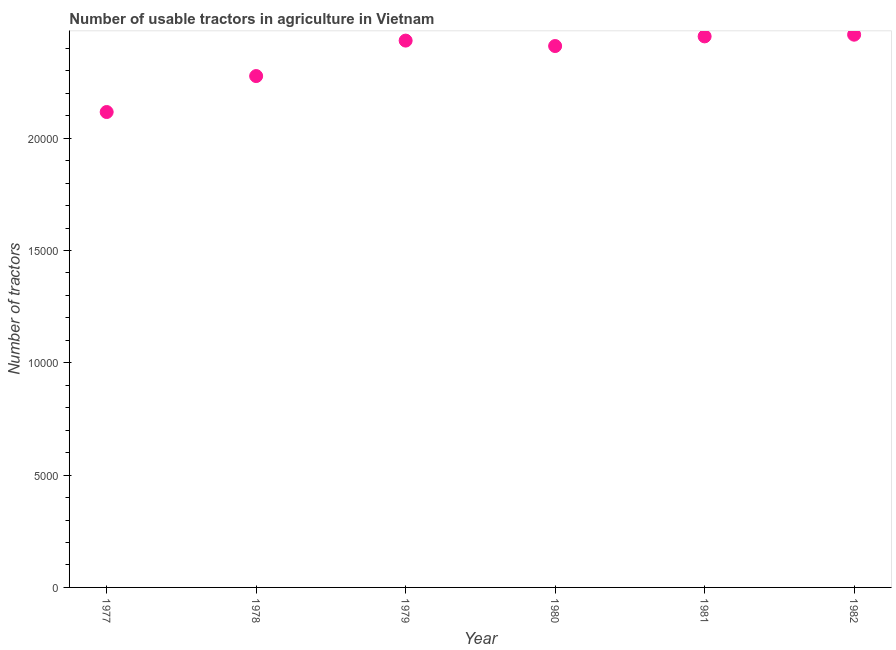What is the number of tractors in 1979?
Keep it short and to the point. 2.43e+04. Across all years, what is the maximum number of tractors?
Your response must be concise. 2.46e+04. Across all years, what is the minimum number of tractors?
Provide a succinct answer. 2.12e+04. In which year was the number of tractors maximum?
Offer a terse response. 1982. What is the sum of the number of tractors?
Provide a short and direct response. 1.42e+05. What is the difference between the number of tractors in 1979 and 1981?
Offer a very short reply. -187. What is the average number of tractors per year?
Offer a terse response. 2.36e+04. What is the median number of tractors?
Keep it short and to the point. 2.42e+04. In how many years, is the number of tractors greater than 8000 ?
Make the answer very short. 6. Do a majority of the years between 1978 and 1979 (inclusive) have number of tractors greater than 22000 ?
Provide a succinct answer. Yes. What is the ratio of the number of tractors in 1977 to that in 1981?
Provide a succinct answer. 0.86. Is the number of tractors in 1979 less than that in 1981?
Keep it short and to the point. Yes. Is the difference between the number of tractors in 1977 and 1982 greater than the difference between any two years?
Your answer should be very brief. Yes. Is the sum of the number of tractors in 1977 and 1979 greater than the maximum number of tractors across all years?
Provide a succinct answer. Yes. What is the difference between the highest and the lowest number of tractors?
Provide a short and direct response. 3443. Does the number of tractors monotonically increase over the years?
Your answer should be very brief. No. How many dotlines are there?
Ensure brevity in your answer.  1. How many years are there in the graph?
Provide a short and direct response. 6. What is the difference between two consecutive major ticks on the Y-axis?
Provide a succinct answer. 5000. Are the values on the major ticks of Y-axis written in scientific E-notation?
Offer a terse response. No. Does the graph contain grids?
Provide a succinct answer. No. What is the title of the graph?
Offer a very short reply. Number of usable tractors in agriculture in Vietnam. What is the label or title of the X-axis?
Offer a very short reply. Year. What is the label or title of the Y-axis?
Provide a succinct answer. Number of tractors. What is the Number of tractors in 1977?
Provide a short and direct response. 2.12e+04. What is the Number of tractors in 1978?
Your answer should be very brief. 2.28e+04. What is the Number of tractors in 1979?
Your answer should be very brief. 2.43e+04. What is the Number of tractors in 1980?
Provide a short and direct response. 2.41e+04. What is the Number of tractors in 1981?
Make the answer very short. 2.45e+04. What is the Number of tractors in 1982?
Your answer should be compact. 2.46e+04. What is the difference between the Number of tractors in 1977 and 1978?
Ensure brevity in your answer.  -1601. What is the difference between the Number of tractors in 1977 and 1979?
Keep it short and to the point. -3180. What is the difference between the Number of tractors in 1977 and 1980?
Your response must be concise. -2938. What is the difference between the Number of tractors in 1977 and 1981?
Provide a succinct answer. -3367. What is the difference between the Number of tractors in 1977 and 1982?
Provide a short and direct response. -3443. What is the difference between the Number of tractors in 1978 and 1979?
Make the answer very short. -1579. What is the difference between the Number of tractors in 1978 and 1980?
Make the answer very short. -1337. What is the difference between the Number of tractors in 1978 and 1981?
Give a very brief answer. -1766. What is the difference between the Number of tractors in 1978 and 1982?
Keep it short and to the point. -1842. What is the difference between the Number of tractors in 1979 and 1980?
Keep it short and to the point. 242. What is the difference between the Number of tractors in 1979 and 1981?
Your response must be concise. -187. What is the difference between the Number of tractors in 1979 and 1982?
Offer a terse response. -263. What is the difference between the Number of tractors in 1980 and 1981?
Provide a succinct answer. -429. What is the difference between the Number of tractors in 1980 and 1982?
Make the answer very short. -505. What is the difference between the Number of tractors in 1981 and 1982?
Give a very brief answer. -76. What is the ratio of the Number of tractors in 1977 to that in 1978?
Your answer should be very brief. 0.93. What is the ratio of the Number of tractors in 1977 to that in 1979?
Ensure brevity in your answer.  0.87. What is the ratio of the Number of tractors in 1977 to that in 1980?
Provide a short and direct response. 0.88. What is the ratio of the Number of tractors in 1977 to that in 1981?
Keep it short and to the point. 0.86. What is the ratio of the Number of tractors in 1977 to that in 1982?
Your answer should be compact. 0.86. What is the ratio of the Number of tractors in 1978 to that in 1979?
Offer a very short reply. 0.94. What is the ratio of the Number of tractors in 1978 to that in 1980?
Offer a very short reply. 0.94. What is the ratio of the Number of tractors in 1978 to that in 1981?
Ensure brevity in your answer.  0.93. What is the ratio of the Number of tractors in 1978 to that in 1982?
Provide a succinct answer. 0.93. What is the ratio of the Number of tractors in 1980 to that in 1981?
Provide a succinct answer. 0.98. What is the ratio of the Number of tractors in 1981 to that in 1982?
Provide a short and direct response. 1. 